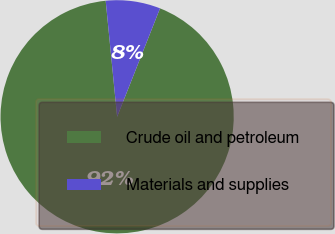<chart> <loc_0><loc_0><loc_500><loc_500><pie_chart><fcel>Crude oil and petroleum<fcel>Materials and supplies<nl><fcel>92.44%<fcel>7.56%<nl></chart> 